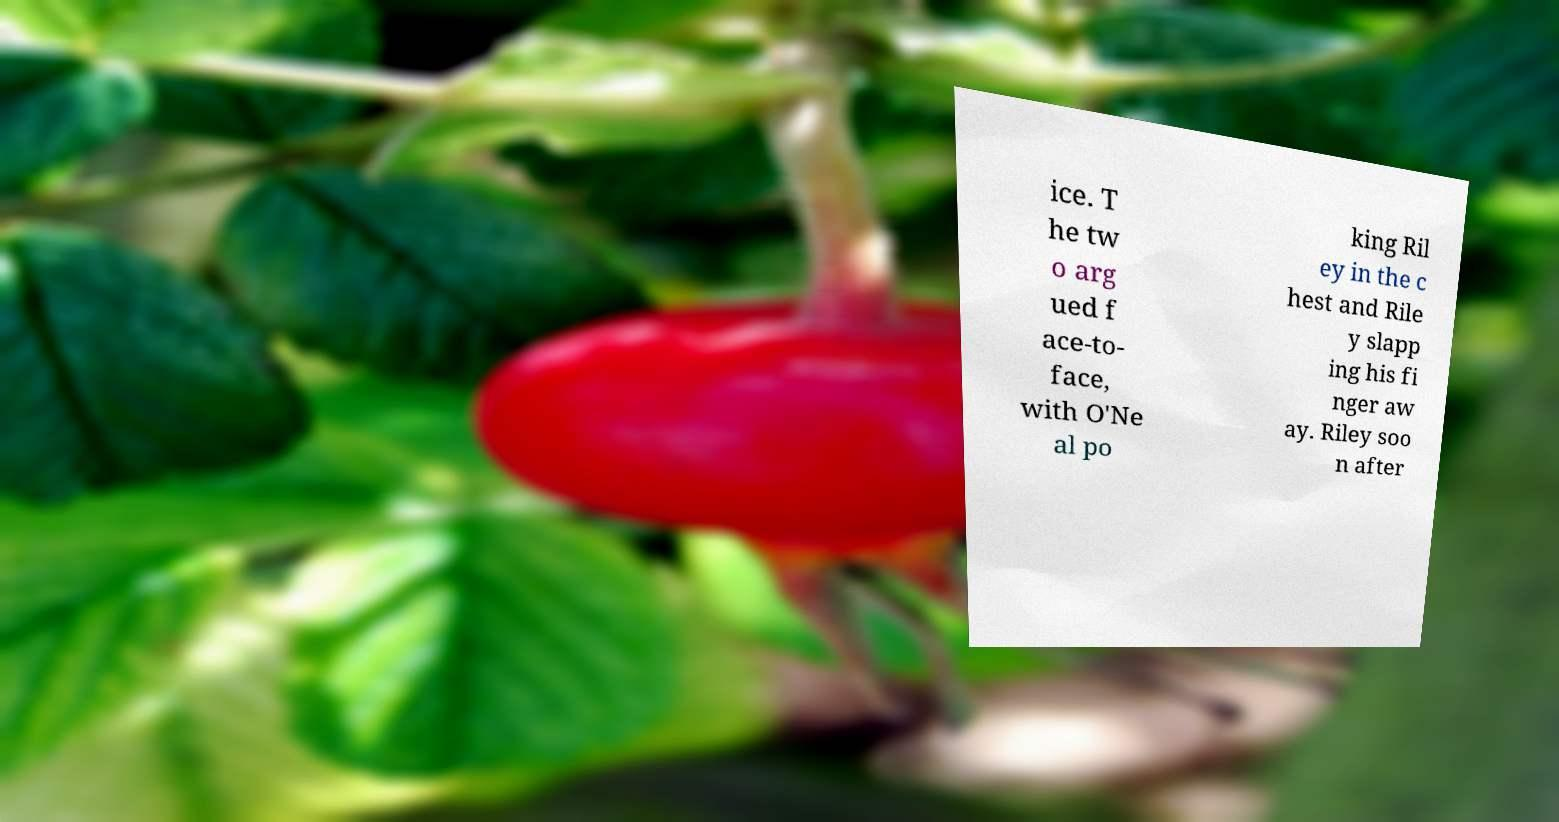For documentation purposes, I need the text within this image transcribed. Could you provide that? ice. T he tw o arg ued f ace-to- face, with O'Ne al po king Ril ey in the c hest and Rile y slapp ing his fi nger aw ay. Riley soo n after 